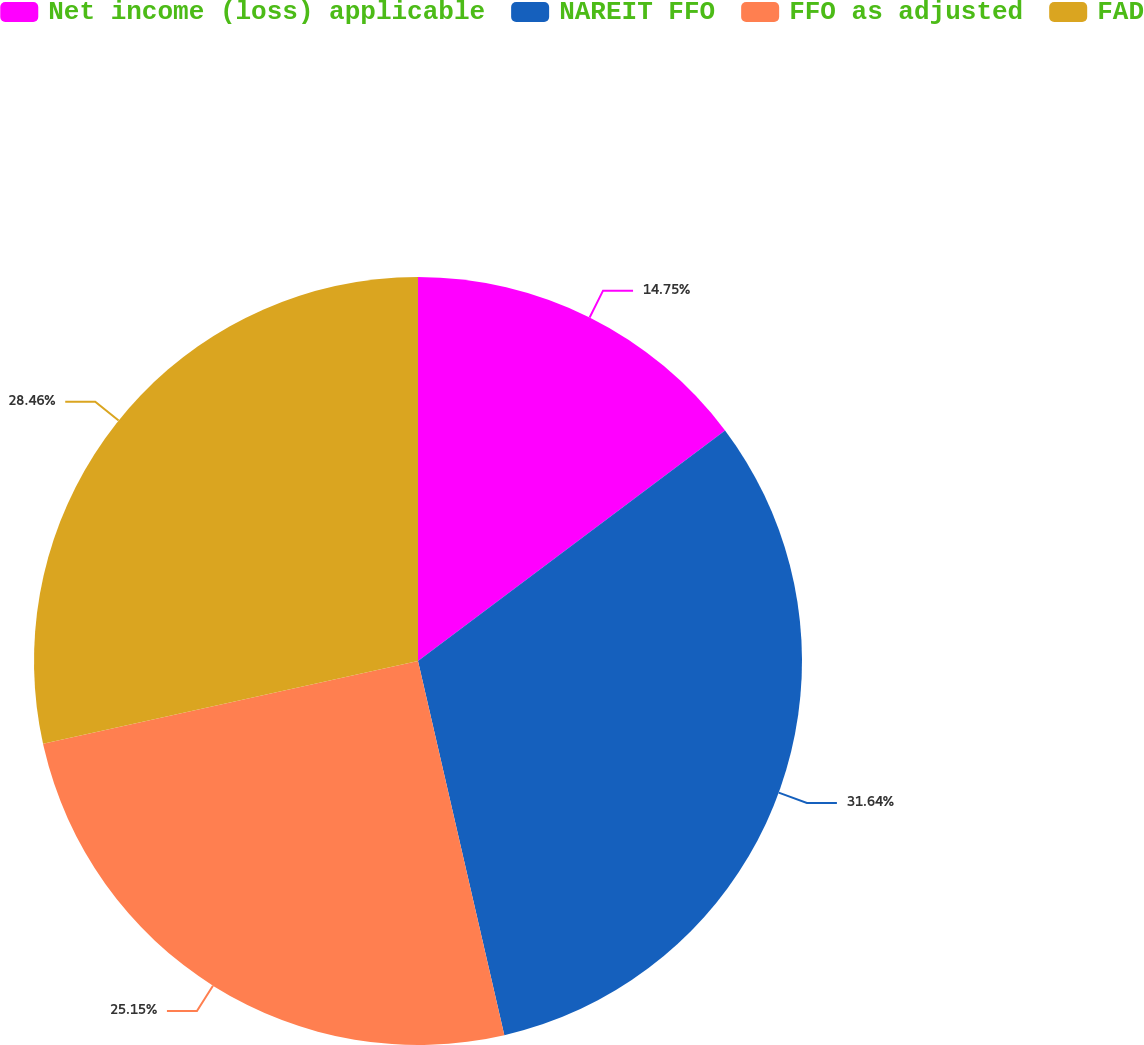Convert chart to OTSL. <chart><loc_0><loc_0><loc_500><loc_500><pie_chart><fcel>Net income (loss) applicable<fcel>NAREIT FFO<fcel>FFO as adjusted<fcel>FAD<nl><fcel>14.75%<fcel>31.64%<fcel>25.15%<fcel>28.46%<nl></chart> 